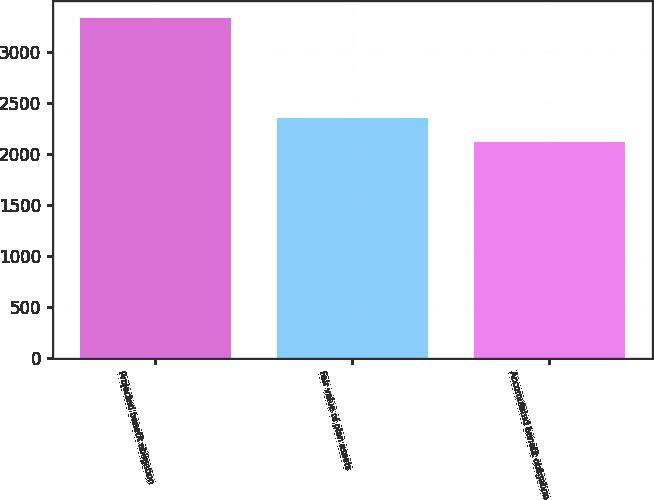Convert chart. <chart><loc_0><loc_0><loc_500><loc_500><bar_chart><fcel>Projected benefit obligation<fcel>Fair value of plan assets<fcel>Accumulated benefit obligation<nl><fcel>3323<fcel>2352<fcel>2120<nl></chart> 